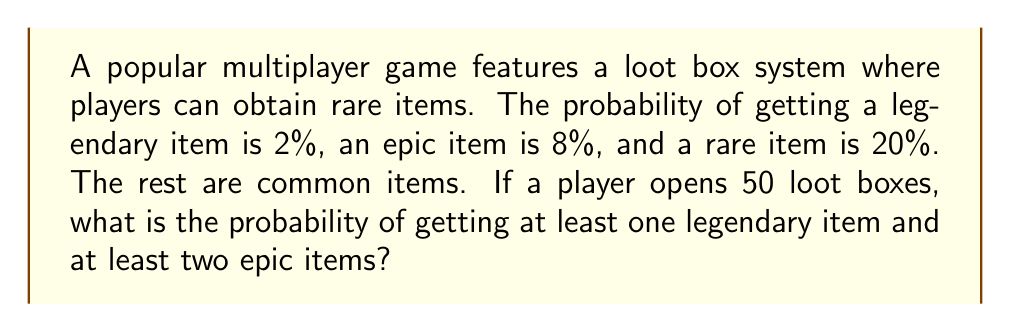Can you answer this question? To solve this problem, we'll use the concept of probability distributions, specifically the binomial distribution.

1. First, let's calculate the probability of not getting a legendary item in 50 tries:
   $P(\text{no legendary}) = (0.98)^{50} \approx 0.3642$

2. Therefore, the probability of getting at least one legendary item is:
   $P(\text{at least one legendary}) = 1 - P(\text{no legendary}) = 1 - 0.3642 = 0.6358$

3. Now, for the epic items, we need to calculate the probability of getting exactly 0 or 1 epic item, and then subtract that from 1 to get the probability of at least two epic items.

4. Using the binomial probability formula:
   $$P(X = k) = \binom{n}{k} p^k (1-p)^{n-k}$$
   where $n = 50$, $p = 0.08$, and $k = 0$ or $1$

5. For $k = 0$:
   $P(X = 0) = \binom{50}{0} (0.08)^0 (0.92)^{50} \approx 0.0158$

6. For $k = 1$:
   $P(X = 1) = \binom{50}{1} (0.08)^1 (0.92)^{49} \approx 0.0687$

7. Probability of getting 0 or 1 epic item:
   $P(X \leq 1) = 0.0158 + 0.0687 = 0.0845$

8. Probability of getting at least two epic items:
   $P(X \geq 2) = 1 - P(X \leq 1) = 1 - 0.0845 = 0.9155$

9. The probability of both events occurring (at least one legendary AND at least two epic items) is the product of their individual probabilities:
   $P(\text{at least one legendary and at least two epic}) = 0.6358 \times 0.9155 = 0.5821$
Answer: The probability of getting at least one legendary item and at least two epic items when opening 50 loot boxes is approximately 0.5821 or 58.21%. 